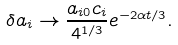Convert formula to latex. <formula><loc_0><loc_0><loc_500><loc_500>\delta a _ { i } \to \frac { a _ { i 0 } c _ { i } } { 4 ^ { 1 / 3 } } e ^ { - 2 \alpha t / 3 } .</formula> 